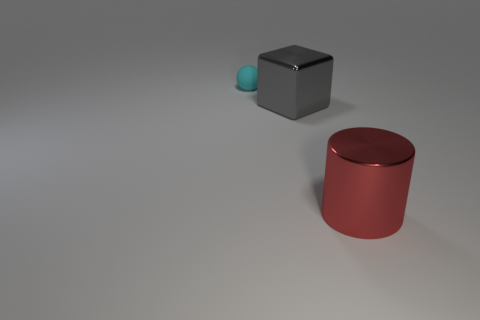Are there any other things that have the same color as the big cylinder? Upon closer inspection of the image, it appears that the smaller sphere shares a similar hue to the large red cylinder, although the shade might slightly differ due to lighting and perspective. 